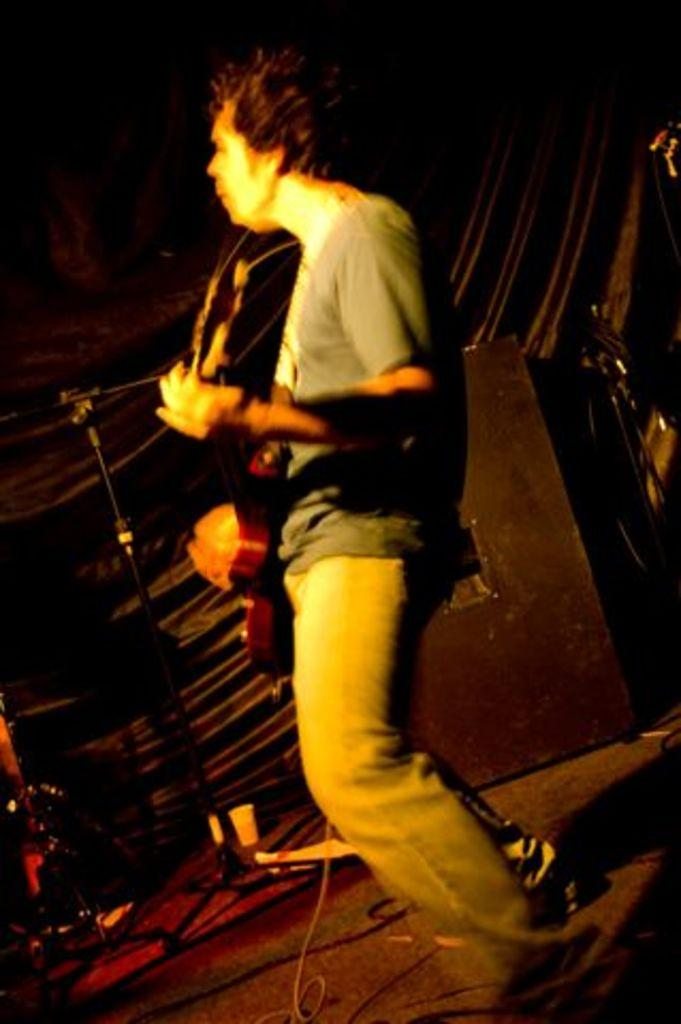What is the main subject of the image? There is a man in the image. What is the man doing in the image? The man is standing and playing a guitar. What other objects are present in the image? There is a microphone and a podium in the image. What type of hook can be seen hanging from the tree in the image? There is no tree or hook present in the image. How many cattle are visible in the image? There are no cattle present in the image. 